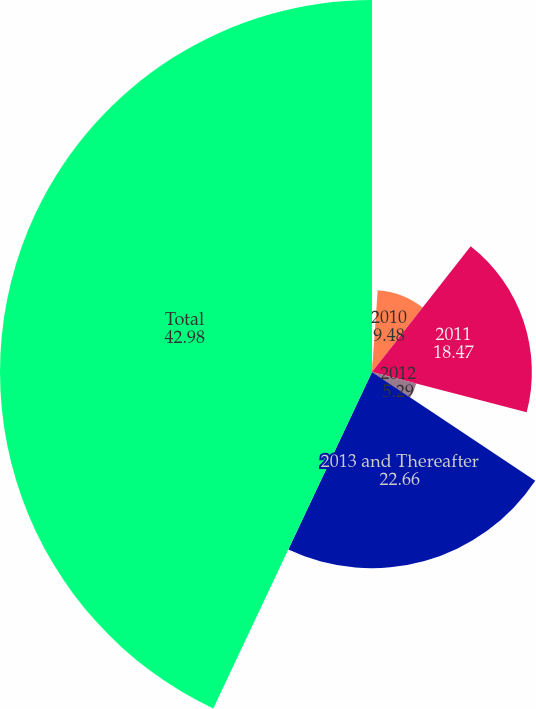Convert chart to OTSL. <chart><loc_0><loc_0><loc_500><loc_500><pie_chart><fcel>2009<fcel>2010<fcel>2011<fcel>2012<fcel>2013 and Thereafter<fcel>Total<nl><fcel>1.11%<fcel>9.48%<fcel>18.47%<fcel>5.29%<fcel>22.66%<fcel>42.98%<nl></chart> 